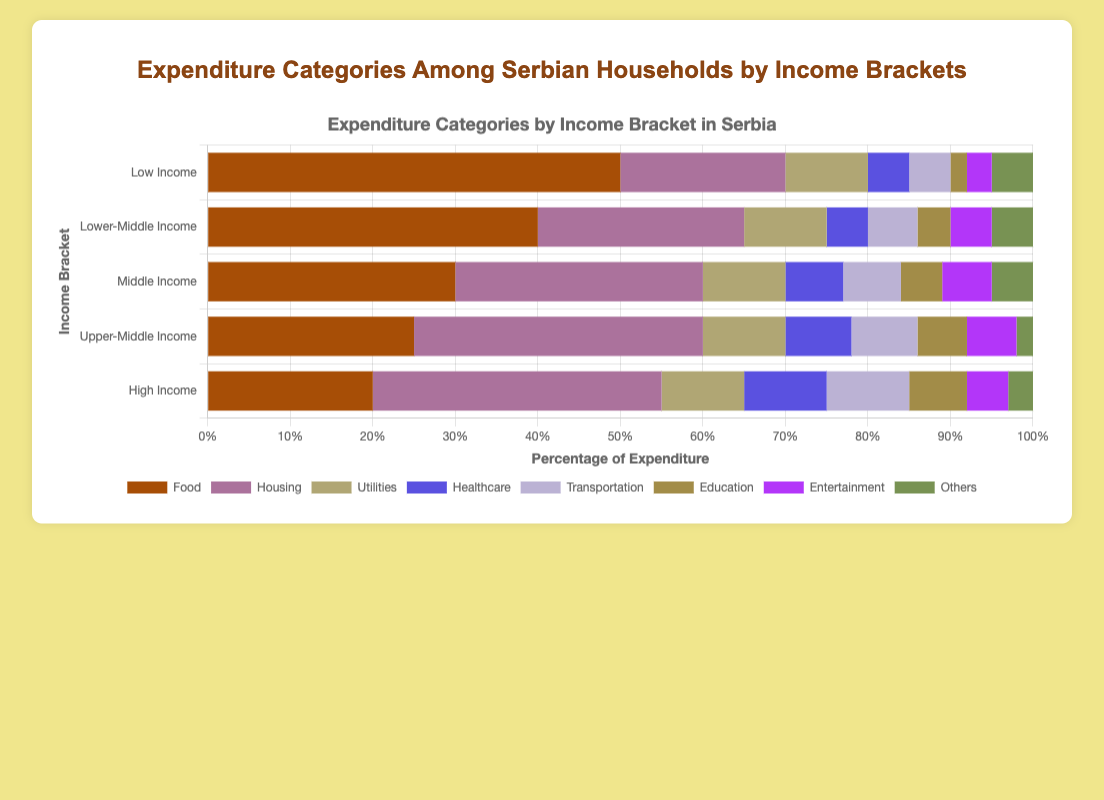What is the total percentage of expenditure on Food and Housing for Low Income households? Add the percentage of expenditure on Food (50%) and Housing (20%). The sum is 50 + 20 = 70%.
Answer: 70% Which income bracket spends the most on Education? Look across all income brackets and compare the percentages of expenditure on Education. The High Income bracket spends 7% on Education, which is the highest among all brackets.
Answer: High Income How does the percentage of expenditure on Transportation compare between Lower-Middle Income and Upper-Middle Income households? Lower-Middle Income households spend 6% on Transportation, while Upper-Middle Income households spend 8%. Therefore, Upper-Middle Income households spend 2% more on Transportation.
Answer: Upper-Middle Income spends 2% more What is the visual difference in the expenditure on Healthcare between High Income and Low Income households? High Income households have a longer bar for Healthcare at 10%, while Low Income households have a shorter bar at 5%. This indicates that High Income households spend twice as much on Healthcare compared to Low Income households.
Answer: High Income spends twice as much What is the average expenditure on Utilities across all income brackets? Sum up the percentages spent on Utilities for all income brackets (10% + 10% + 10% + 10% + 10% = 50%) and then divide by the number of brackets (5). The average is 50/5 = 10%.
Answer: 10% Among the categories Food, Housing, and Utilities, which has the smallest percentage expenditure in the High Income bracket? Compare the percentages of Food (20%), Housing (35%), and Utilities (10%) in the High Income bracket. Utilities at 10% is the smallest.
Answer: Utilities What is the difference in the percentage of expenditure on Entertainment between the Middle Income and Low Income brackets? Middle Income households spend 6% on Entertainment whereas Low Income households spend 3% on Entertainment. The difference is 6% - 3% = 3%.
Answer: 3% If we add the expenditures on Food and Transportation, which category (Healthcare, Education or Entertainment) has the same or closest average expenditure across all income brackets? Sum the percentages for Food (50+40+30+25+20) and Transportation (5+6+7+8+10), then calculate average expenditure for each: 
Food = 50+40+30+25+20 = 165, average = 165/5 = 33%
Transportation = 5+6+7+8+10 = 36, average = 36/5 = 7.2%
Now find the average for Healthcare, Education, and Entertainment:
Healthcare = (5+5+7+8+10)/5 = 7%
Education = (2+4+5+6+7)/5 = 4.8%
Entertainment = (3+5+6+6+5)/5 = 5%
Transportation has the average closest to Healthcare with an average of 7%.
Answer: Healthcare Which bracket spends the least percentage on Others? Compare the percentages spent on Others across all brackets: Low Income (5%), Lower-Middle Income (5%), Middle Income (5%), Upper-Middle Income (2%), High Income (3%). The Upper-Middle Income bracket spends the least on Others.
Answer: Upper-Middle Income 